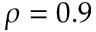<formula> <loc_0><loc_0><loc_500><loc_500>\rho = 0 . 9</formula> 